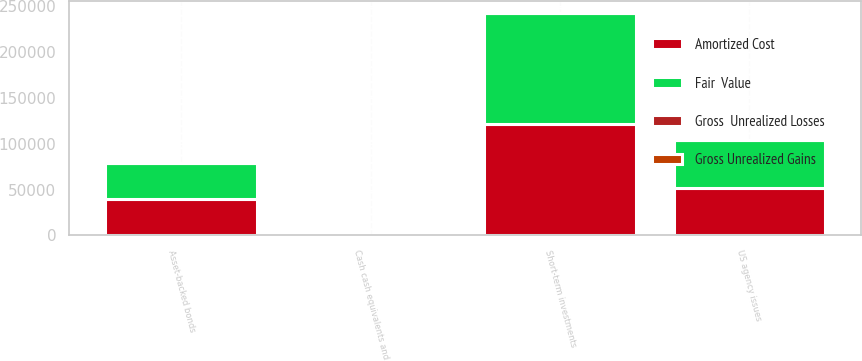Convert chart to OTSL. <chart><loc_0><loc_0><loc_500><loc_500><stacked_bar_chart><ecel><fcel>US agency issues<fcel>Asset-backed bonds<fcel>Short-term investments<fcel>Cash cash equivalents and<nl><fcel>Fair  Value<fcel>52055<fcel>39224<fcel>121266<fcel>221<nl><fcel>Gross  Unrealized Losses<fcel>65<fcel>122<fcel>221<fcel>221<nl><fcel>Gross Unrealized Gains<fcel>12<fcel>75<fcel>87<fcel>87<nl><fcel>Amortized Cost<fcel>52108<fcel>39271<fcel>121400<fcel>221<nl></chart> 